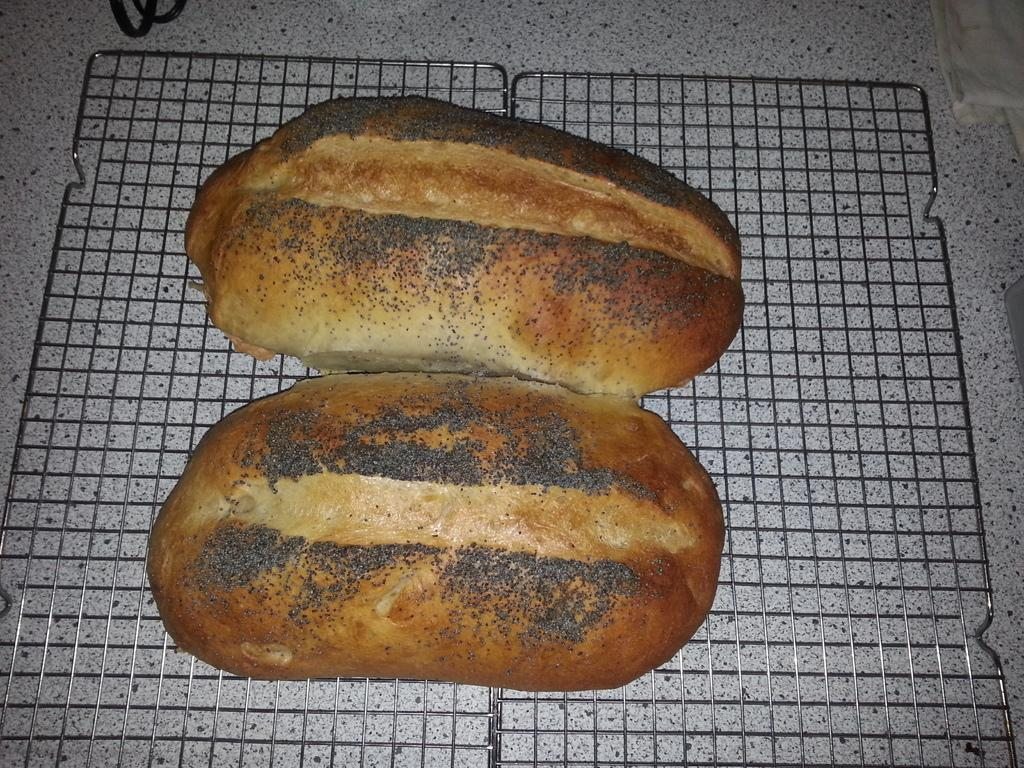What type of bread is shown in the image? There are two sourdoughs in the image. How are the sourdoughs positioned in the image? The sourdoughs are placed on a grill. What color is the background of the image? The background of the image is white. Where was the image taken? The image was taken inside a room. What type of dress is the guitar wearing in the image? There is no guitar or dress present in the image; it features two sourdoughs placed on a grill. 